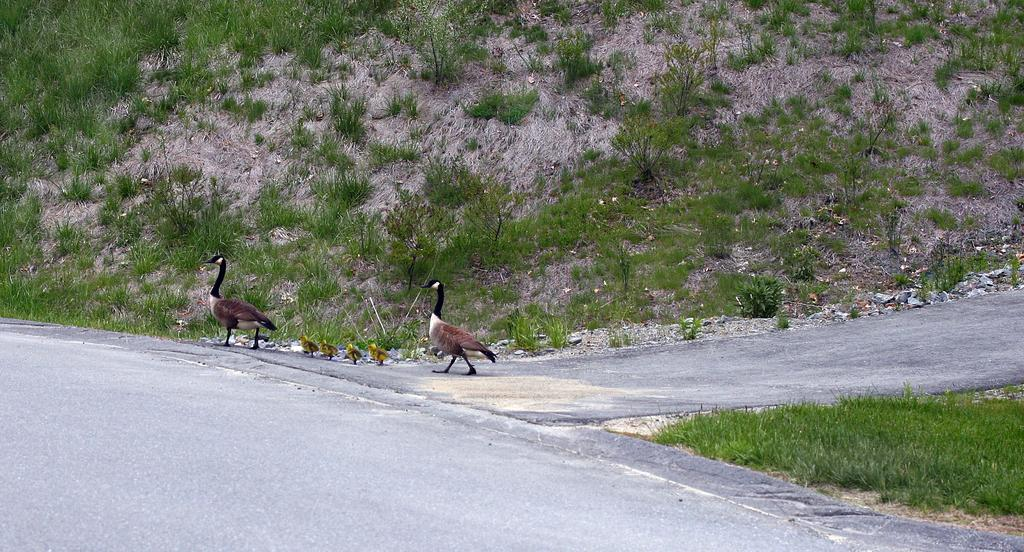What type of vegetation is present on the land in the image? There is grass on the land in the image. Where are the birds located in the image? The birds are on the road in the image. How many trees can be seen in the image? There is no tree present in the image; it only features grass and birds on the road. Can you spot a giraffe or a frog in the image? Neither a giraffe nor a frog is present in the image. 